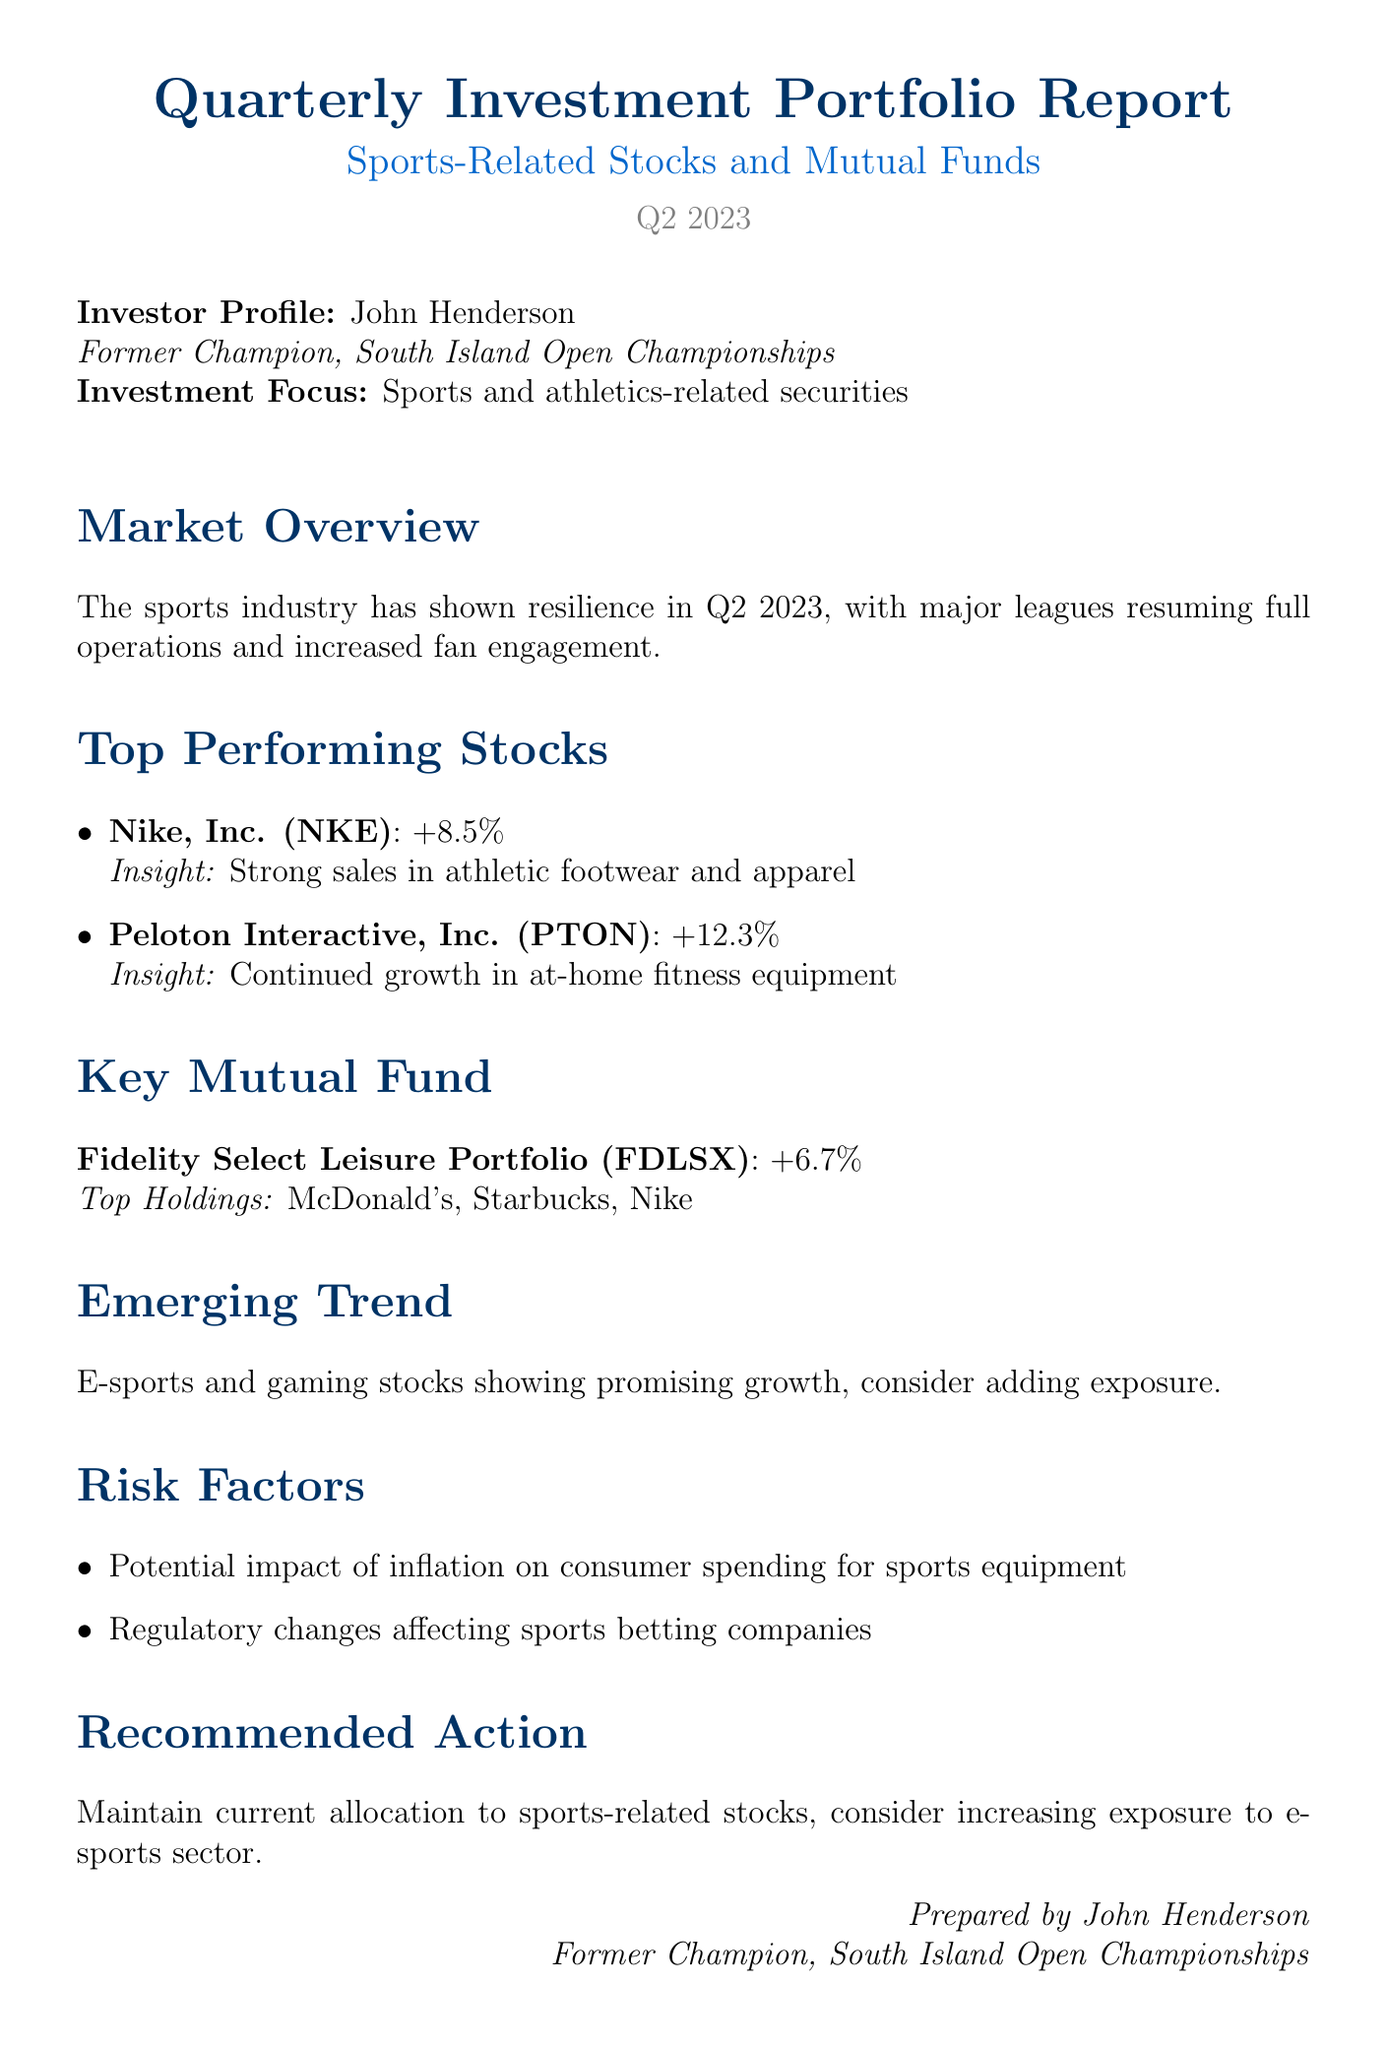What is the report title? The report title is specified at the beginning of the document, which indicates the purpose and focus area.
Answer: Quarterly Investment Portfolio Report: Sports-Related Stocks and Mutual Funds Who is the investor? The investor's name is provided in the investor profile section of the document.
Answer: John Henderson What is the performance of Peloton Interactive, Inc. (PTON)? The performance metric for Peloton is included under the top-performing stocks section.
Answer: +12.3% Which mutual fund is highlighted in the report? The key mutual fund name is mentioned explicitly in the report.
Answer: Fidelity Select Leisure Portfolio (FDLSX) What emerging trend is discussed in the report? The document mentions specific trends that are relevant to current investment opportunities.
Answer: E-sports and gaming stocks showing promising growth What is the recommended action in the report? The recommendation is outlined at the end of the report for investors' guidance.
Answer: Maintain current allocation to sports-related stocks, consider increasing exposure to e-sports sector What risk factor relates to inflation? A specific risk factor regarding consumer behavior and economics is mentioned in the risk factors section.
Answer: Potential impact of inflation on consumer spending for sports equipment What was the performance of Nike, Inc. (NKE)? The performance of Nike is provided as part of the top-performing stocks information.
Answer: +8.5% 